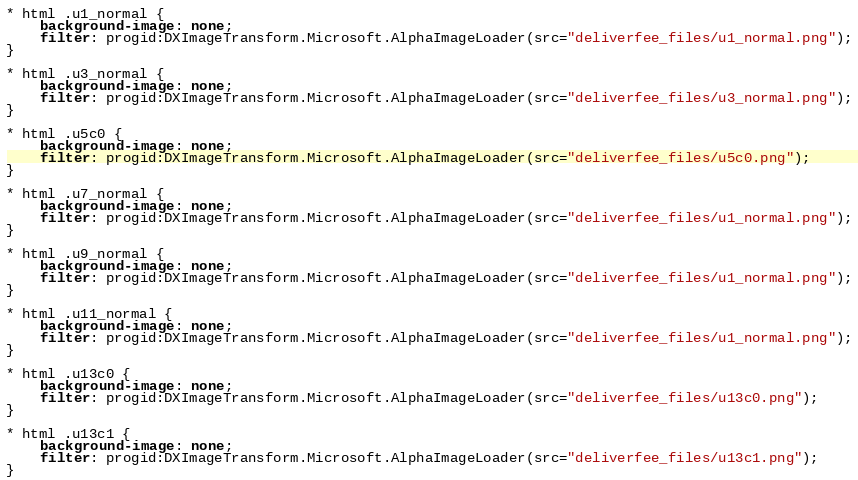<code> <loc_0><loc_0><loc_500><loc_500><_CSS_>* html .u1_normal {
    background-image: none;
    filter: progid:DXImageTransform.Microsoft.AlphaImageLoader(src="deliverfee_files/u1_normal.png");
}

* html .u3_normal {
    background-image: none;
    filter: progid:DXImageTransform.Microsoft.AlphaImageLoader(src="deliverfee_files/u3_normal.png");
}

* html .u5c0 {
    background-image: none;
    filter: progid:DXImageTransform.Microsoft.AlphaImageLoader(src="deliverfee_files/u5c0.png");
}

* html .u7_normal {
    background-image: none;
    filter: progid:DXImageTransform.Microsoft.AlphaImageLoader(src="deliverfee_files/u1_normal.png");
}

* html .u9_normal {
    background-image: none;
    filter: progid:DXImageTransform.Microsoft.AlphaImageLoader(src="deliverfee_files/u1_normal.png");
}

* html .u11_normal {
    background-image: none;
    filter: progid:DXImageTransform.Microsoft.AlphaImageLoader(src="deliverfee_files/u1_normal.png");
}

* html .u13c0 {
    background-image: none;
    filter: progid:DXImageTransform.Microsoft.AlphaImageLoader(src="deliverfee_files/u13c0.png");
}

* html .u13c1 {
    background-image: none;
    filter: progid:DXImageTransform.Microsoft.AlphaImageLoader(src="deliverfee_files/u13c1.png");
}
</code> 